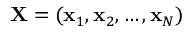<formula> <loc_0><loc_0><loc_500><loc_500>X = ( x _ { 1 } , x _ { 2 } , \dots , x _ { N } )</formula> 